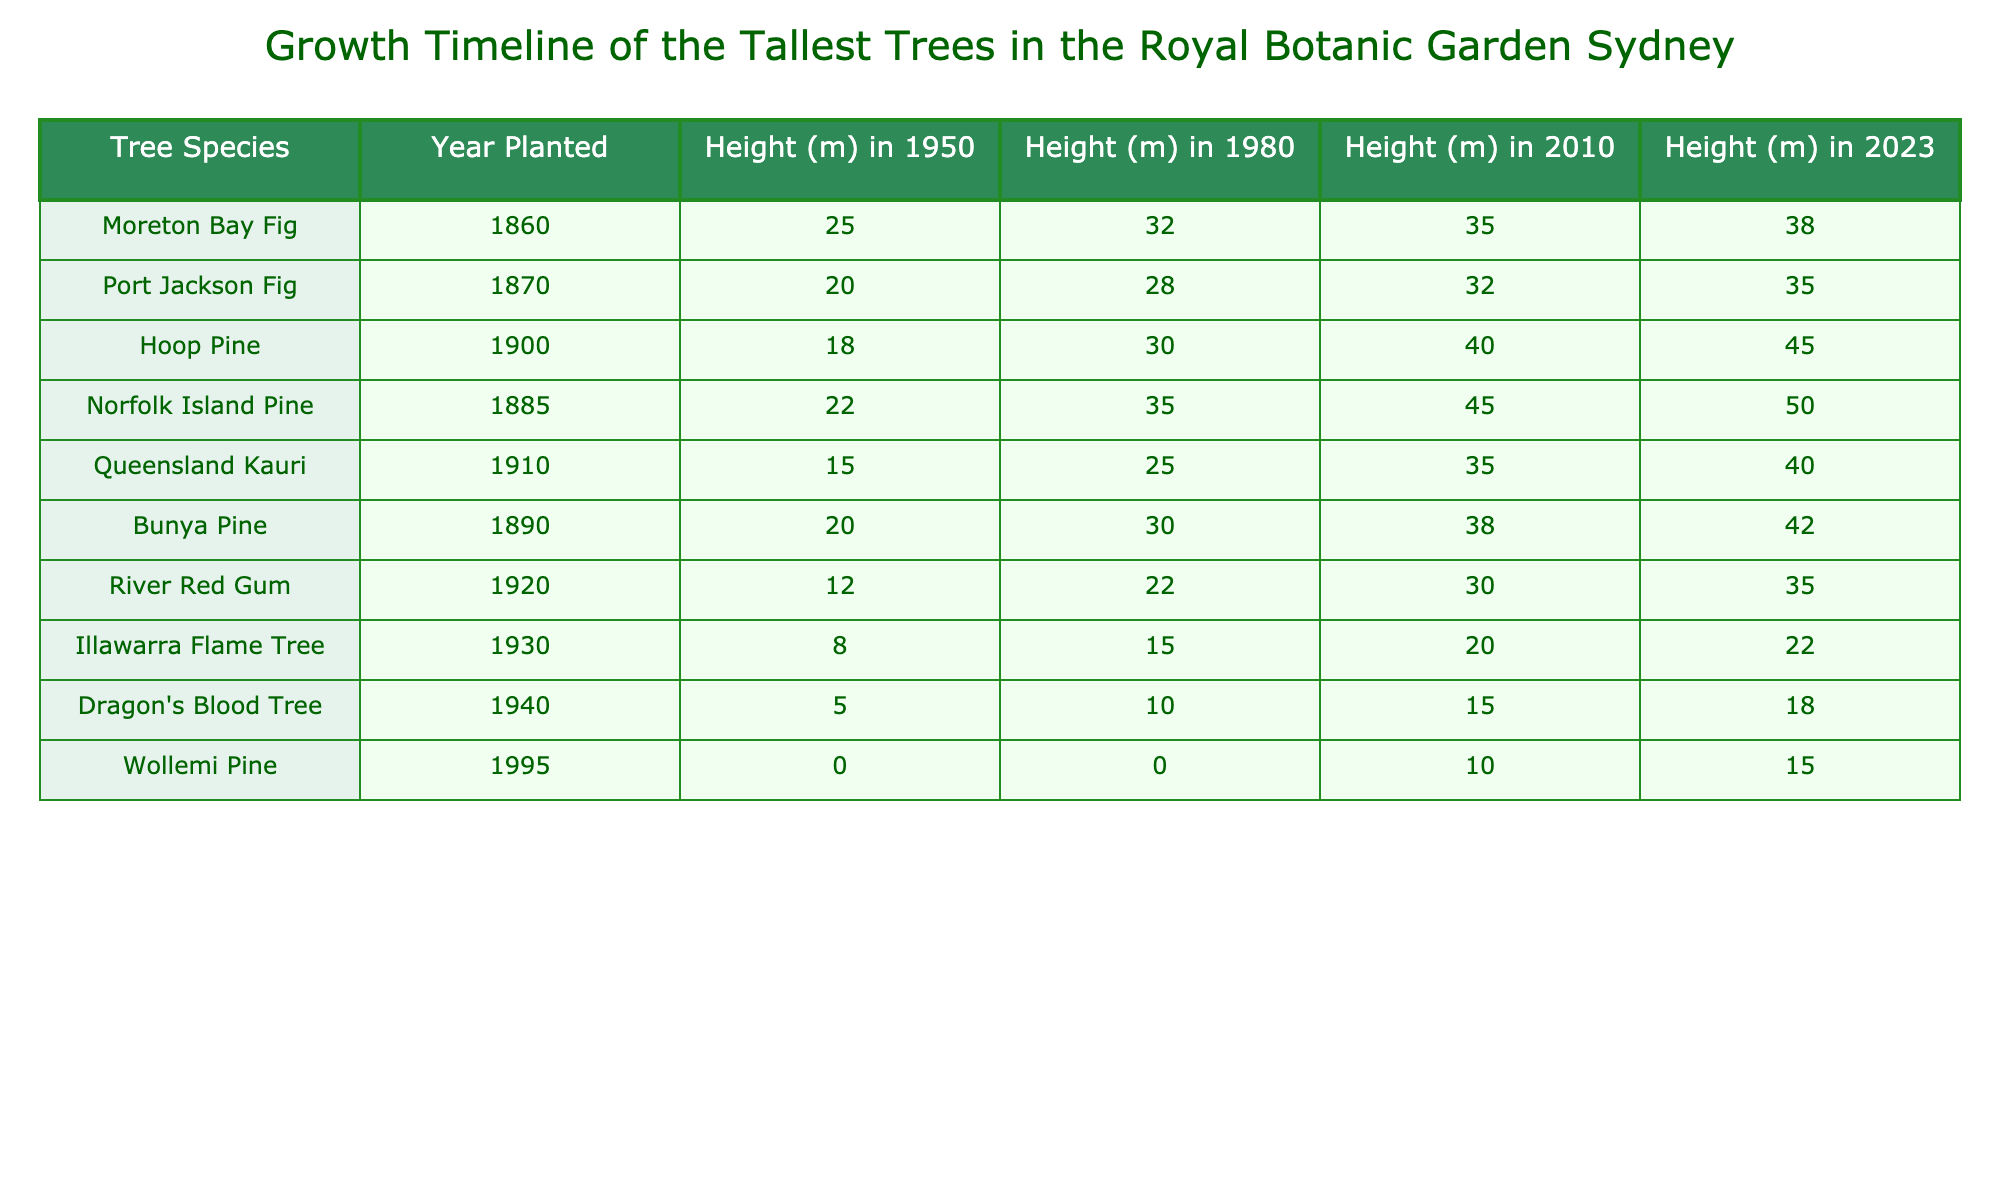What year was the Norfolk Island Pine planted? Referring to the table, the Norfolk Island Pine is listed under the Year Planted column and shows the year 1885.
Answer: 1885 Which tree species had the highest height in 2023? Looking at the Height (m) in 2023 column, the Norfolk Island Pine shows the maximum height of 50 meters.
Answer: Norfolk Island Pine What was the height increase of the Hoop Pine from 1950 to 2023? The height of the Hoop Pine in 1950 was 18 meters, and in 2023 it was 45 meters. Therefore, the increase is 45 - 18 = 27 meters.
Answer: 27 meters What is the average height of the trees in 2010? First, we identify the heights in 2010: 35, 32, 40, 45, 35, 38, 30, 20, 15, 10, 0. Adding these gives 35 + 32 + 40 + 45 + 35 + 38 + 30 + 20 + 15 + 10 + 0 = 360 meters. There are 11 data points, so the average is 360/11 ≈ 32.73 meters.
Answer: Approximately 32.73 meters Is the River Red Gum taller in 2023 than it was in 1980? The height of the River Red Gum in 2023 is 35 meters, compared to 22 meters in 1980. Since 35 is greater than 22, the statement is true.
Answer: Yes What is the total height of trees in 1980? The heights in 1980 are: 32, 28, 30, 35, 25, 30, 22, 15, 10, 0. Adding these gives 32 + 28 + 30 + 35 + 25 + 30 + 22 + 15 + 10 + 0 =  302 meters.
Answer: 302 meters Which tree species had the lowest height in 2010? The heights of all trees in 2010 are 35, 32, 40, 45, 35, 38, 30, 20, 15, 10, 0. The lowest height corresponds to the Wollemi Pine, which is 10 meters tall in 2010.
Answer: Wollemi Pine What is the percentage increase in height of the Moreton Bay Fig from 1950 to 2023? The height of the Moreton Bay Fig increased from 25 meters in 1950 to 38 meters in 2023. The increase is 38 - 25 = 13 meters. The percentage increase is (13/25) * 100 = 52%.
Answer: 52% Do any trees have the same height in 1980 and 2023? Reviewing the heights, the Port Jackson Fig was 28 meters in 1980 and is 35 meters in 2023, while the Dragon's Blood Tree was 10 meters in 1980 and 18 meters in 2023. No tree has the same height in both years; thus, the statement is false.
Answer: No Which species has the smallest height in the last measured year, 2023? The Wollemi Pine in 2023 is recorded at 15 meters, which is the smallest height compared to all other species listed.
Answer: Wollemi Pine How much taller is the Bunya Pine in 2023 compared to its height in 1980? The height of the Bunya Pine in 1980 was 30 meters, and in 2023 it is 42 meters. The difference is 42 - 30 = 12 meters.
Answer: 12 meters 